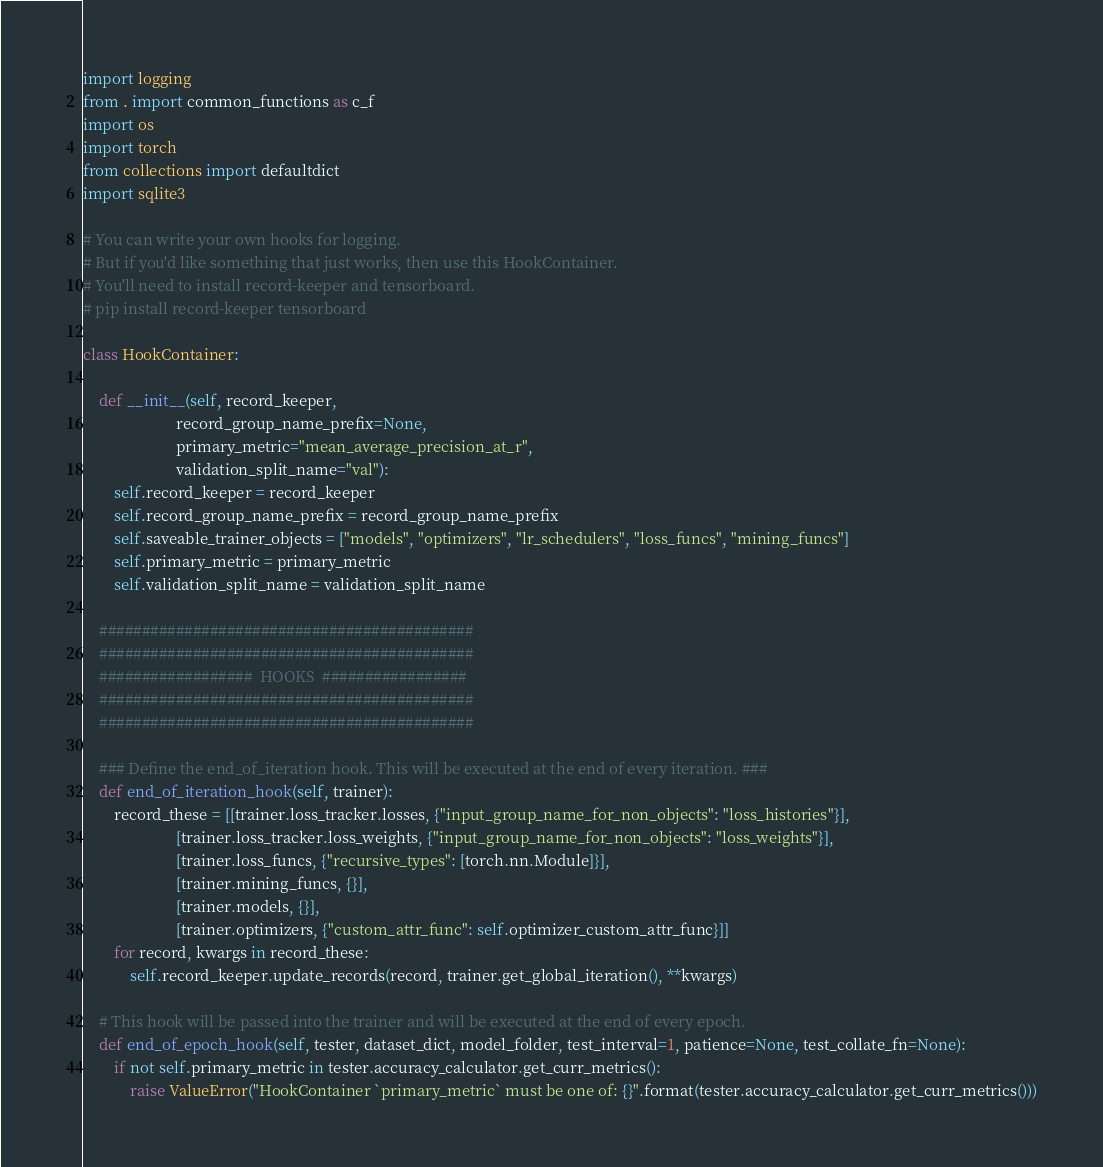Convert code to text. <code><loc_0><loc_0><loc_500><loc_500><_Python_>import logging
from . import common_functions as c_f
import os
import torch
from collections import defaultdict
import sqlite3

# You can write your own hooks for logging.
# But if you'd like something that just works, then use this HookContainer.
# You'll need to install record-keeper and tensorboard.
# pip install record-keeper tensorboard

class HookContainer: 

    def __init__(self, record_keeper, 
                        record_group_name_prefix=None, 
                        primary_metric="mean_average_precision_at_r", 
                        validation_split_name="val"):
        self.record_keeper = record_keeper
        self.record_group_name_prefix = record_group_name_prefix
        self.saveable_trainer_objects = ["models", "optimizers", "lr_schedulers", "loss_funcs", "mining_funcs"]
        self.primary_metric = primary_metric
        self.validation_split_name = validation_split_name

    ############################################
    ############################################
    ##################  HOOKS  #################
    ############################################
    ############################################

    ### Define the end_of_iteration hook. This will be executed at the end of every iteration. ###
    def end_of_iteration_hook(self, trainer):
        record_these = [[trainer.loss_tracker.losses, {"input_group_name_for_non_objects": "loss_histories"}],
                        [trainer.loss_tracker.loss_weights, {"input_group_name_for_non_objects": "loss_weights"}],
                        [trainer.loss_funcs, {"recursive_types": [torch.nn.Module]}],
                        [trainer.mining_funcs, {}],
                        [trainer.models, {}],
                        [trainer.optimizers, {"custom_attr_func": self.optimizer_custom_attr_func}]]
        for record, kwargs in record_these:
            self.record_keeper.update_records(record, trainer.get_global_iteration(), **kwargs)

    # This hook will be passed into the trainer and will be executed at the end of every epoch.
    def end_of_epoch_hook(self, tester, dataset_dict, model_folder, test_interval=1, patience=None, test_collate_fn=None):
        if not self.primary_metric in tester.accuracy_calculator.get_curr_metrics():
            raise ValueError("HookContainer `primary_metric` must be one of: {}".format(tester.accuracy_calculator.get_curr_metrics()))</code> 